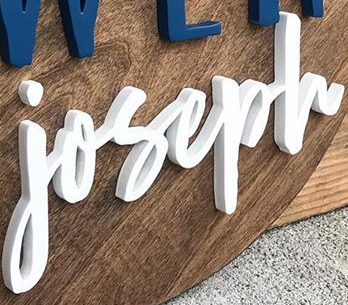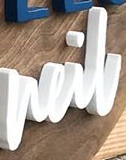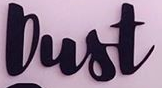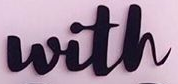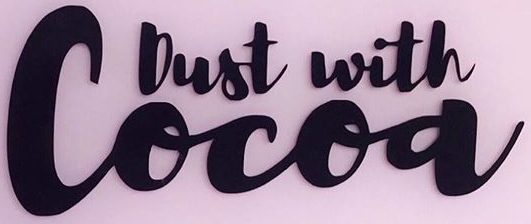What words can you see in these images in sequence, separated by a semicolon? joseph; neil; Dust; with; Cocoa 